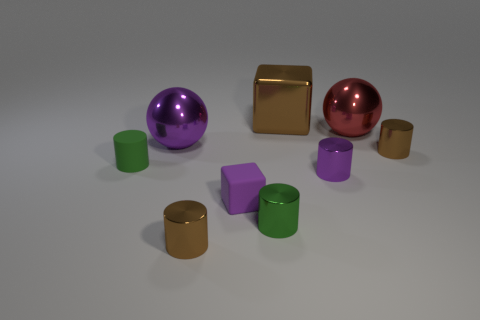Subtract all blue spheres. How many brown cylinders are left? 2 Subtract all matte cylinders. How many cylinders are left? 4 Subtract all green cylinders. How many cylinders are left? 3 Add 1 big red balls. How many objects exist? 10 Subtract 1 cylinders. How many cylinders are left? 4 Subtract all balls. How many objects are left? 7 Subtract all gray blocks. Subtract all brown balls. How many blocks are left? 2 Subtract all small purple cylinders. Subtract all tiny green metallic cylinders. How many objects are left? 7 Add 4 green matte objects. How many green matte objects are left? 5 Add 6 yellow metallic cylinders. How many yellow metallic cylinders exist? 6 